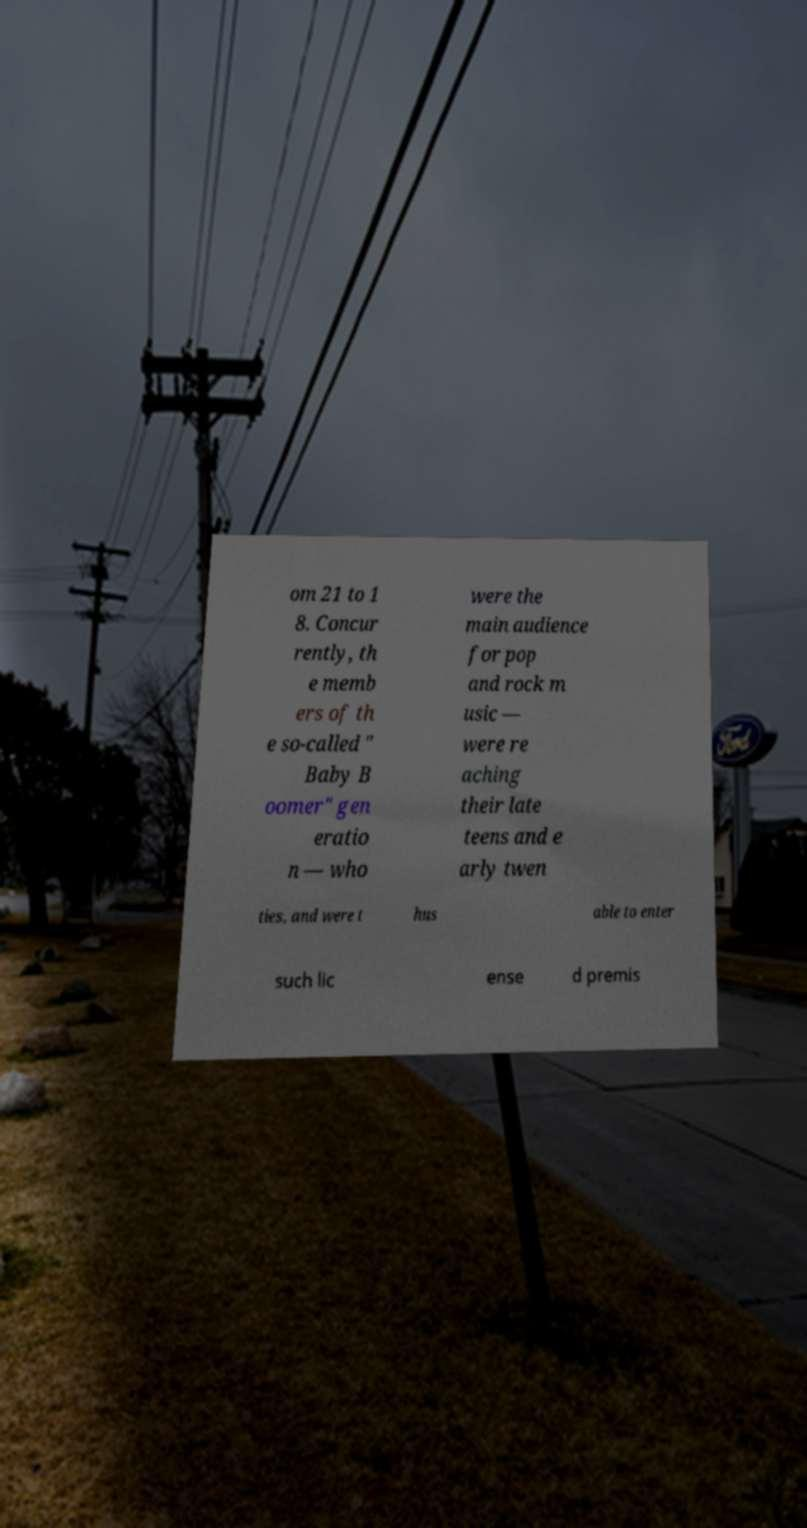What messages or text are displayed in this image? I need them in a readable, typed format. om 21 to 1 8. Concur rently, th e memb ers of th e so-called " Baby B oomer" gen eratio n — who were the main audience for pop and rock m usic — were re aching their late teens and e arly twen ties, and were t hus able to enter such lic ense d premis 